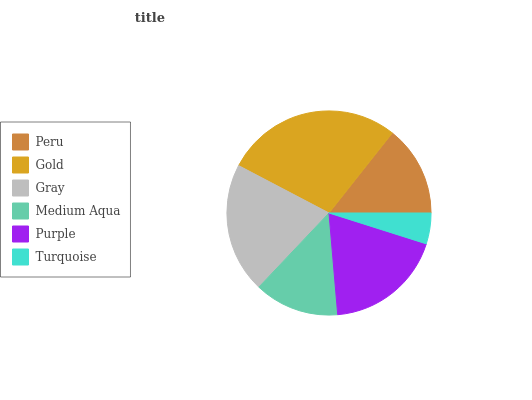Is Turquoise the minimum?
Answer yes or no. Yes. Is Gold the maximum?
Answer yes or no. Yes. Is Gray the minimum?
Answer yes or no. No. Is Gray the maximum?
Answer yes or no. No. Is Gold greater than Gray?
Answer yes or no. Yes. Is Gray less than Gold?
Answer yes or no. Yes. Is Gray greater than Gold?
Answer yes or no. No. Is Gold less than Gray?
Answer yes or no. No. Is Purple the high median?
Answer yes or no. Yes. Is Peru the low median?
Answer yes or no. Yes. Is Turquoise the high median?
Answer yes or no. No. Is Purple the low median?
Answer yes or no. No. 